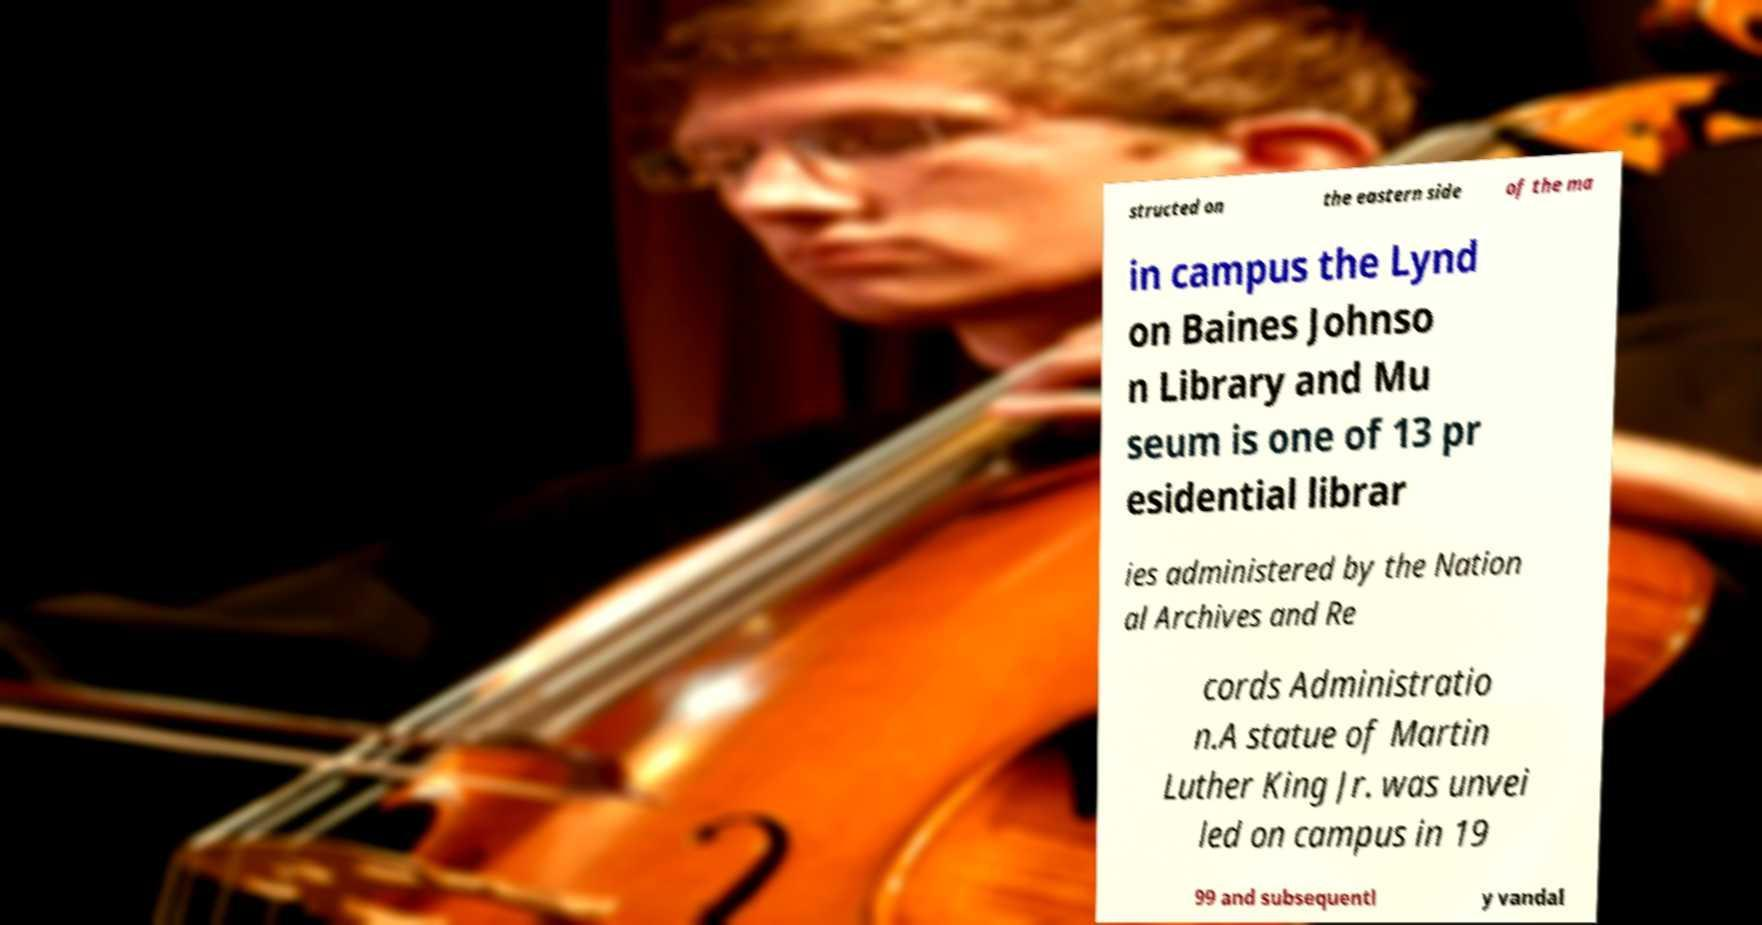What messages or text are displayed in this image? I need them in a readable, typed format. structed on the eastern side of the ma in campus the Lynd on Baines Johnso n Library and Mu seum is one of 13 pr esidential librar ies administered by the Nation al Archives and Re cords Administratio n.A statue of Martin Luther King Jr. was unvei led on campus in 19 99 and subsequentl y vandal 